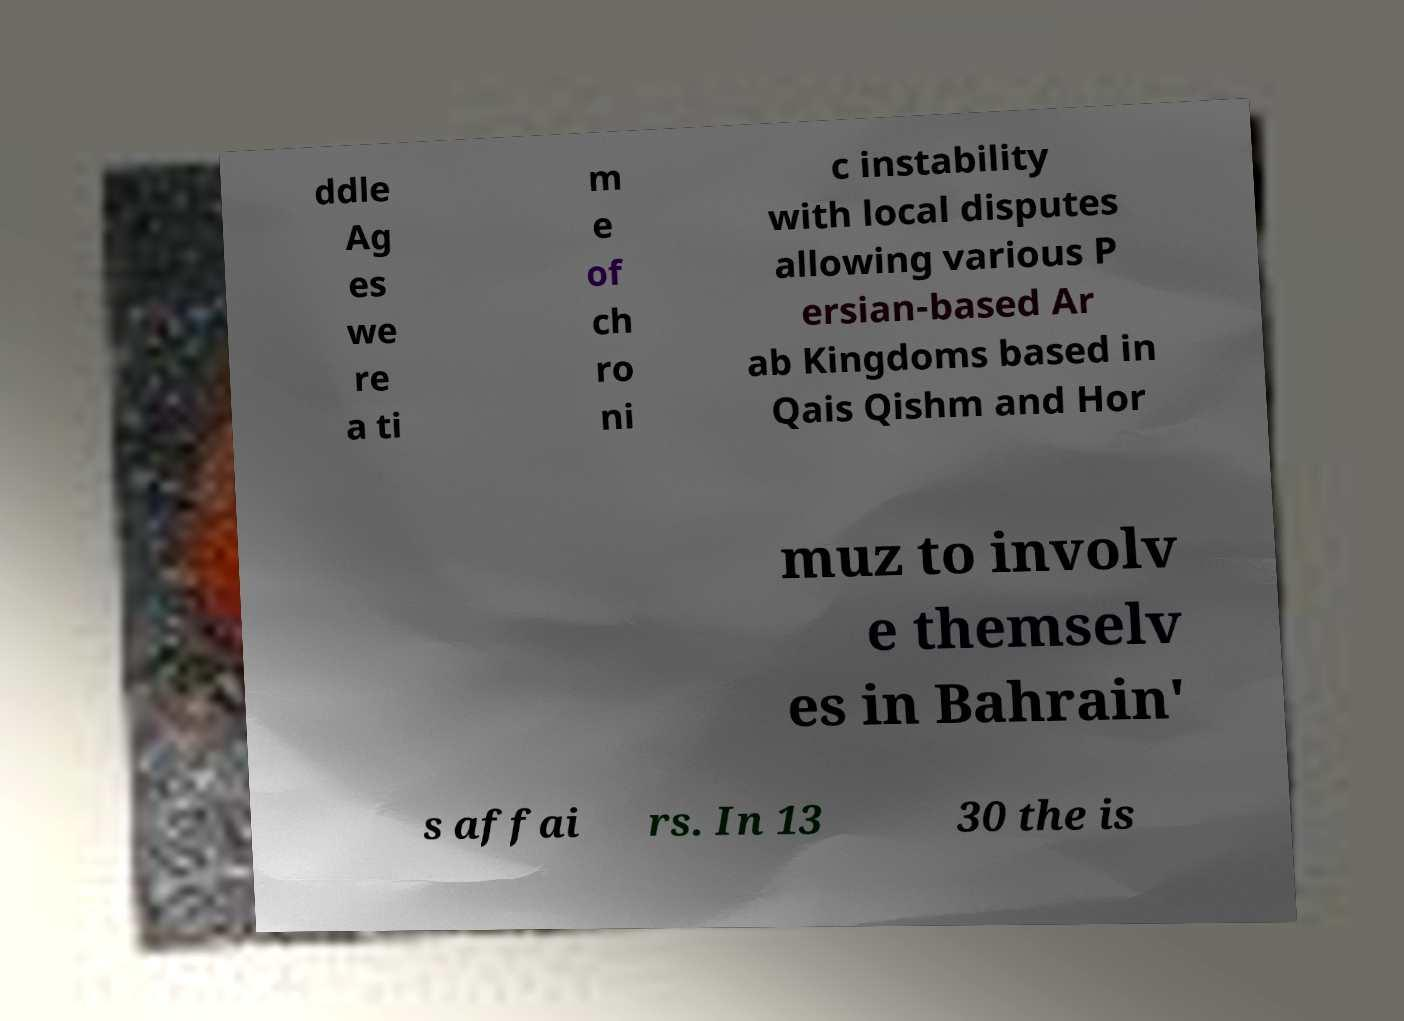For documentation purposes, I need the text within this image transcribed. Could you provide that? ddle Ag es we re a ti m e of ch ro ni c instability with local disputes allowing various P ersian-based Ar ab Kingdoms based in Qais Qishm and Hor muz to involv e themselv es in Bahrain' s affai rs. In 13 30 the is 